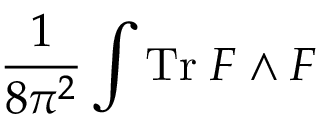<formula> <loc_0><loc_0><loc_500><loc_500>\frac { 1 } { 8 \pi ^ { 2 } } \int T r \, F \wedge F</formula> 